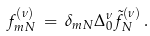<formula> <loc_0><loc_0><loc_500><loc_500>f _ { m N } ^ { ( \nu ) } \, = \, \delta _ { m N } \Delta _ { 0 } ^ { \nu } \tilde { f } _ { N } ^ { ( \nu ) } \, .</formula> 